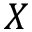<formula> <loc_0><loc_0><loc_500><loc_500>X</formula> 